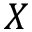<formula> <loc_0><loc_0><loc_500><loc_500>X</formula> 